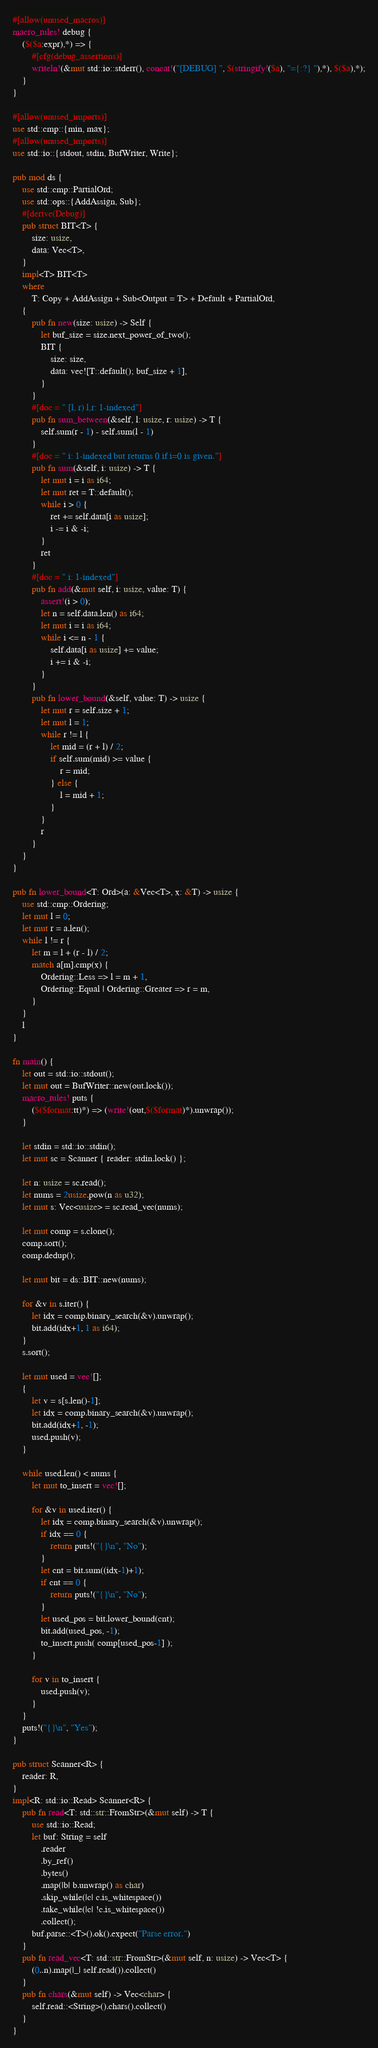Convert code to text. <code><loc_0><loc_0><loc_500><loc_500><_Rust_>#[allow(unused_macros)]
macro_rules! debug {
    ($($a:expr),*) => {
        #[cfg(debug_assertions)]
        writeln!(&mut std::io::stderr(), concat!("[DEBUG] ", $(stringify!($a), "={:?} "),*), $($a),*);
    }
}

#[allow(unused_imports)]
use std::cmp::{min, max};
#[allow(unused_imports)]
use std::io::{stdout, stdin, BufWriter, Write};

pub mod ds {
    use std::cmp::PartialOrd;
    use std::ops::{AddAssign, Sub};
    #[derive(Debug)]
    pub struct BIT<T> {
        size: usize,
        data: Vec<T>,
    }
    impl<T> BIT<T>
    where
        T: Copy + AddAssign + Sub<Output = T> + Default + PartialOrd,
    {
        pub fn new(size: usize) -> Self {
            let buf_size = size.next_power_of_two();
            BIT {
                size: size,
                data: vec![T::default(); buf_size + 1],
            }
        }
        #[doc = " [l, r) l,r: 1-indexed"]
        pub fn sum_between(&self, l: usize, r: usize) -> T {
            self.sum(r - 1) - self.sum(l - 1)
        }
        #[doc = " i: 1-indexed but returns 0 if i=0 is given."]
        pub fn sum(&self, i: usize) -> T {
            let mut i = i as i64;
            let mut ret = T::default();
            while i > 0 {
                ret += self.data[i as usize];
                i -= i & -i;
            }
            ret
        }
        #[doc = " i: 1-indexed"]
        pub fn add(&mut self, i: usize, value: T) {
            assert!(i > 0);
            let n = self.data.len() as i64;
            let mut i = i as i64;
            while i <= n - 1 {
                self.data[i as usize] += value;
                i += i & -i;
            }
        }
        pub fn lower_bound(&self, value: T) -> usize {
            let mut r = self.size + 1;
            let mut l = 1;
            while r != l {
                let mid = (r + l) / 2;
                if self.sum(mid) >= value {
                    r = mid;
                } else {
                    l = mid + 1;
                }
            }
            r
        }
    }
}

pub fn lower_bound<T: Ord>(a: &Vec<T>, x: &T) -> usize {
    use std::cmp::Ordering;
    let mut l = 0;
    let mut r = a.len();
    while l != r {
        let m = l + (r - l) / 2;
        match a[m].cmp(x) {
            Ordering::Less => l = m + 1,
            Ordering::Equal | Ordering::Greater => r = m,
        }
    }
    l
}

fn main() {
    let out = std::io::stdout();
    let mut out = BufWriter::new(out.lock());
    macro_rules! puts {
        ($($format:tt)*) => (write!(out,$($format)*).unwrap());
    }

    let stdin = std::io::stdin();
    let mut sc = Scanner { reader: stdin.lock() };

    let n: usize = sc.read();
    let nums = 2usize.pow(n as u32);
    let mut s: Vec<usize> = sc.read_vec(nums);

    let mut comp = s.clone();
    comp.sort();
    comp.dedup();

    let mut bit = ds::BIT::new(nums);

    for &v in s.iter() {
        let idx = comp.binary_search(&v).unwrap();
        bit.add(idx+1, 1 as i64);
    }
    s.sort();

    let mut used = vec![];
    {
        let v = s[s.len()-1];
        let idx = comp.binary_search(&v).unwrap();
        bit.add(idx+1, -1);
        used.push(v);
    }

    while used.len() < nums {
        let mut to_insert = vec![];

        for &v in used.iter() {
            let idx = comp.binary_search(&v).unwrap();
            if idx == 0 {
                return puts!("{}\n", "No");
            }
            let cnt = bit.sum((idx-1)+1);
            if cnt == 0 {
                return puts!("{}\n", "No");
            }
            let used_pos = bit.lower_bound(cnt);
            bit.add(used_pos, -1);
            to_insert.push( comp[used_pos-1] );
        }

        for v in to_insert {
            used.push(v);
        }
    }
    puts!("{}\n", "Yes");
}

pub struct Scanner<R> {
    reader: R,
}
impl<R: std::io::Read> Scanner<R> {
    pub fn read<T: std::str::FromStr>(&mut self) -> T {
        use std::io::Read;
        let buf: String = self
            .reader
            .by_ref()
            .bytes()
            .map(|b| b.unwrap() as char)
            .skip_while(|c| c.is_whitespace())
            .take_while(|c| !c.is_whitespace())
            .collect();
        buf.parse::<T>().ok().expect("Parse error.")
    }
    pub fn read_vec<T: std::str::FromStr>(&mut self, n: usize) -> Vec<T> {
        (0..n).map(|_| self.read()).collect()
    }
    pub fn chars(&mut self) -> Vec<char> {
        self.read::<String>().chars().collect()
    }
}</code> 